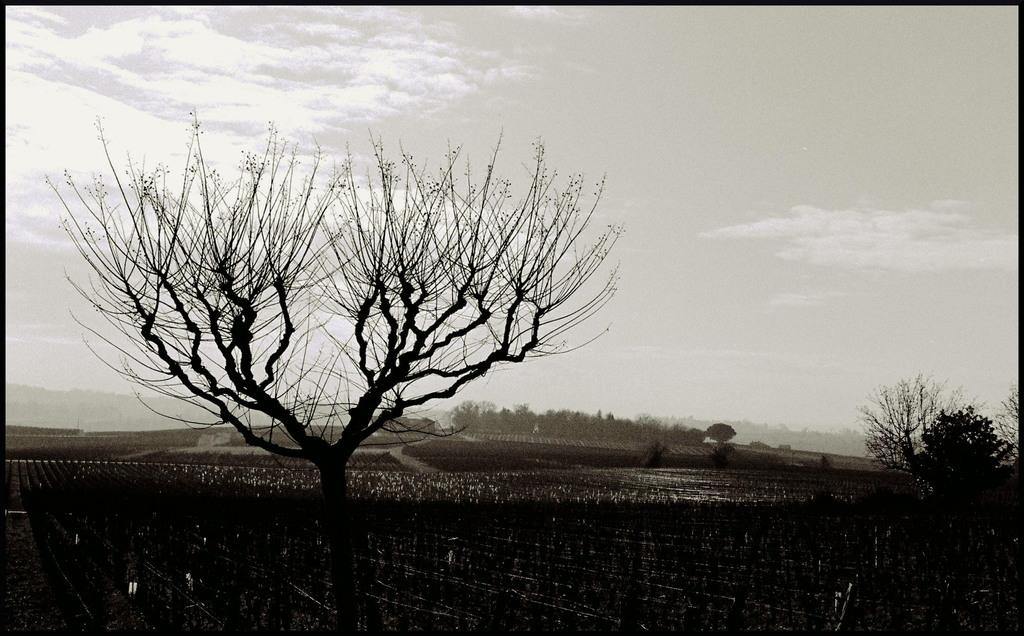What type of landscape is depicted in the image? There is a field in the image. What other natural elements can be seen in the image? There are trees in the image. Can you describe the background of the image? In the background of the image, there are trees, and the sky is visible. What can be observed in the sky? Clouds are present in the sky. What type of comfort can be provided by the lawyer in the image? There is no lawyer present in the image; it features a field and trees. 